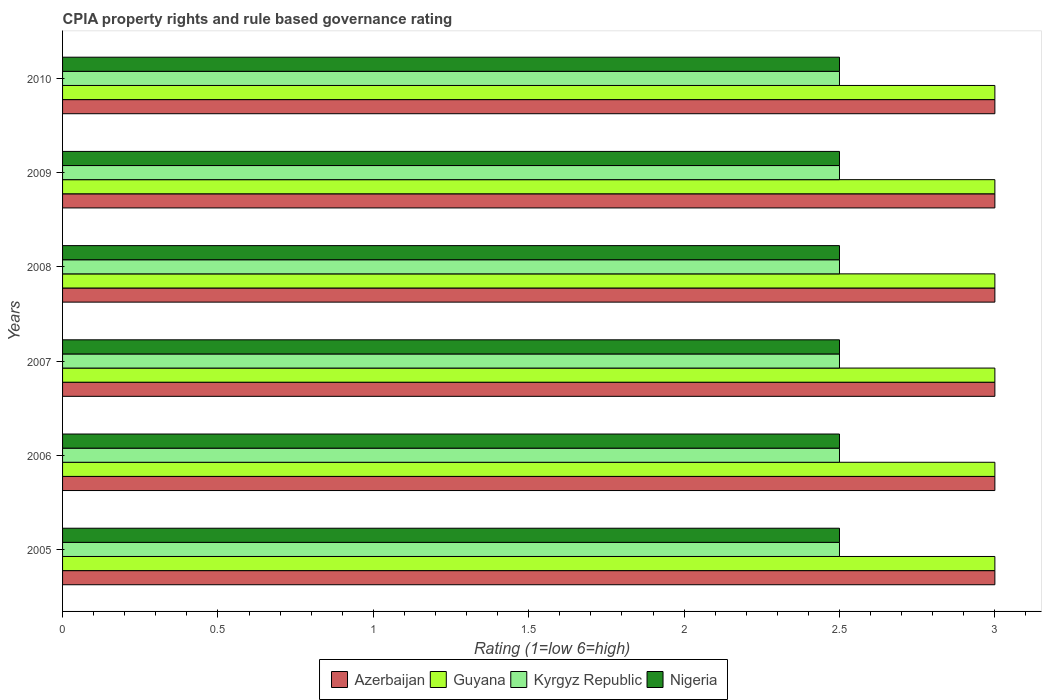How many groups of bars are there?
Make the answer very short. 6. Are the number of bars per tick equal to the number of legend labels?
Provide a short and direct response. Yes. Are the number of bars on each tick of the Y-axis equal?
Your answer should be very brief. Yes. How many bars are there on the 1st tick from the top?
Your answer should be very brief. 4. How many bars are there on the 4th tick from the bottom?
Keep it short and to the point. 4. What is the label of the 5th group of bars from the top?
Provide a succinct answer. 2006. In how many cases, is the number of bars for a given year not equal to the number of legend labels?
Give a very brief answer. 0. What is the total CPIA rating in Kyrgyz Republic in the graph?
Keep it short and to the point. 15. What is the difference between the CPIA rating in Azerbaijan in 2005 and that in 2006?
Your response must be concise. 0. In the year 2010, what is the difference between the CPIA rating in Guyana and CPIA rating in Azerbaijan?
Provide a succinct answer. 0. In how many years, is the CPIA rating in Kyrgyz Republic greater than 1.6 ?
Provide a short and direct response. 6. What is the ratio of the CPIA rating in Guyana in 2006 to that in 2010?
Give a very brief answer. 1. Is the sum of the CPIA rating in Kyrgyz Republic in 2005 and 2009 greater than the maximum CPIA rating in Nigeria across all years?
Ensure brevity in your answer.  Yes. Is it the case that in every year, the sum of the CPIA rating in Nigeria and CPIA rating in Kyrgyz Republic is greater than the sum of CPIA rating in Azerbaijan and CPIA rating in Guyana?
Ensure brevity in your answer.  No. What does the 2nd bar from the top in 2006 represents?
Make the answer very short. Kyrgyz Republic. What does the 2nd bar from the bottom in 2009 represents?
Give a very brief answer. Guyana. Is it the case that in every year, the sum of the CPIA rating in Kyrgyz Republic and CPIA rating in Nigeria is greater than the CPIA rating in Guyana?
Your answer should be very brief. Yes. Does the graph contain grids?
Make the answer very short. No. What is the title of the graph?
Provide a succinct answer. CPIA property rights and rule based governance rating. What is the label or title of the X-axis?
Give a very brief answer. Rating (1=low 6=high). What is the Rating (1=low 6=high) of Azerbaijan in 2005?
Your answer should be very brief. 3. What is the Rating (1=low 6=high) in Kyrgyz Republic in 2006?
Provide a short and direct response. 2.5. What is the Rating (1=low 6=high) in Nigeria in 2006?
Your answer should be compact. 2.5. What is the Rating (1=low 6=high) in Nigeria in 2007?
Make the answer very short. 2.5. What is the Rating (1=low 6=high) of Azerbaijan in 2008?
Provide a short and direct response. 3. What is the Rating (1=low 6=high) of Guyana in 2008?
Your response must be concise. 3. What is the Rating (1=low 6=high) of Guyana in 2009?
Offer a very short reply. 3. What is the Rating (1=low 6=high) of Nigeria in 2009?
Offer a very short reply. 2.5. What is the Rating (1=low 6=high) in Azerbaijan in 2010?
Your response must be concise. 3. What is the Rating (1=low 6=high) of Nigeria in 2010?
Your response must be concise. 2.5. Across all years, what is the maximum Rating (1=low 6=high) of Azerbaijan?
Keep it short and to the point. 3. Across all years, what is the maximum Rating (1=low 6=high) of Guyana?
Give a very brief answer. 3. Across all years, what is the maximum Rating (1=low 6=high) in Nigeria?
Your answer should be very brief. 2.5. Across all years, what is the minimum Rating (1=low 6=high) of Azerbaijan?
Keep it short and to the point. 3. Across all years, what is the minimum Rating (1=low 6=high) of Kyrgyz Republic?
Offer a very short reply. 2.5. What is the total Rating (1=low 6=high) of Azerbaijan in the graph?
Your answer should be very brief. 18. What is the total Rating (1=low 6=high) of Guyana in the graph?
Your response must be concise. 18. What is the total Rating (1=low 6=high) of Kyrgyz Republic in the graph?
Ensure brevity in your answer.  15. What is the difference between the Rating (1=low 6=high) of Guyana in 2005 and that in 2006?
Your response must be concise. 0. What is the difference between the Rating (1=low 6=high) in Kyrgyz Republic in 2005 and that in 2007?
Your response must be concise. 0. What is the difference between the Rating (1=low 6=high) of Nigeria in 2005 and that in 2007?
Provide a succinct answer. 0. What is the difference between the Rating (1=low 6=high) of Azerbaijan in 2005 and that in 2008?
Give a very brief answer. 0. What is the difference between the Rating (1=low 6=high) in Guyana in 2005 and that in 2008?
Your response must be concise. 0. What is the difference between the Rating (1=low 6=high) of Kyrgyz Republic in 2005 and that in 2008?
Make the answer very short. 0. What is the difference between the Rating (1=low 6=high) in Nigeria in 2005 and that in 2008?
Offer a terse response. 0. What is the difference between the Rating (1=low 6=high) in Azerbaijan in 2005 and that in 2009?
Provide a succinct answer. 0. What is the difference between the Rating (1=low 6=high) of Kyrgyz Republic in 2005 and that in 2009?
Provide a short and direct response. 0. What is the difference between the Rating (1=low 6=high) in Azerbaijan in 2005 and that in 2010?
Make the answer very short. 0. What is the difference between the Rating (1=low 6=high) in Kyrgyz Republic in 2005 and that in 2010?
Give a very brief answer. 0. What is the difference between the Rating (1=low 6=high) in Nigeria in 2005 and that in 2010?
Your answer should be very brief. 0. What is the difference between the Rating (1=low 6=high) of Nigeria in 2006 and that in 2007?
Keep it short and to the point. 0. What is the difference between the Rating (1=low 6=high) of Guyana in 2006 and that in 2008?
Offer a terse response. 0. What is the difference between the Rating (1=low 6=high) of Nigeria in 2006 and that in 2008?
Your response must be concise. 0. What is the difference between the Rating (1=low 6=high) of Guyana in 2006 and that in 2009?
Offer a very short reply. 0. What is the difference between the Rating (1=low 6=high) in Kyrgyz Republic in 2006 and that in 2009?
Your response must be concise. 0. What is the difference between the Rating (1=low 6=high) in Azerbaijan in 2006 and that in 2010?
Make the answer very short. 0. What is the difference between the Rating (1=low 6=high) of Guyana in 2006 and that in 2010?
Your response must be concise. 0. What is the difference between the Rating (1=low 6=high) of Kyrgyz Republic in 2006 and that in 2010?
Your answer should be compact. 0. What is the difference between the Rating (1=low 6=high) of Azerbaijan in 2007 and that in 2008?
Ensure brevity in your answer.  0. What is the difference between the Rating (1=low 6=high) in Azerbaijan in 2007 and that in 2009?
Your response must be concise. 0. What is the difference between the Rating (1=low 6=high) of Kyrgyz Republic in 2007 and that in 2009?
Give a very brief answer. 0. What is the difference between the Rating (1=low 6=high) in Nigeria in 2007 and that in 2009?
Your response must be concise. 0. What is the difference between the Rating (1=low 6=high) of Azerbaijan in 2008 and that in 2009?
Keep it short and to the point. 0. What is the difference between the Rating (1=low 6=high) in Guyana in 2008 and that in 2009?
Offer a very short reply. 0. What is the difference between the Rating (1=low 6=high) of Kyrgyz Republic in 2008 and that in 2009?
Keep it short and to the point. 0. What is the difference between the Rating (1=low 6=high) in Nigeria in 2008 and that in 2009?
Your answer should be compact. 0. What is the difference between the Rating (1=low 6=high) of Guyana in 2008 and that in 2010?
Ensure brevity in your answer.  0. What is the difference between the Rating (1=low 6=high) in Kyrgyz Republic in 2008 and that in 2010?
Provide a short and direct response. 0. What is the difference between the Rating (1=low 6=high) in Nigeria in 2008 and that in 2010?
Your response must be concise. 0. What is the difference between the Rating (1=low 6=high) of Guyana in 2009 and that in 2010?
Provide a short and direct response. 0. What is the difference between the Rating (1=low 6=high) in Kyrgyz Republic in 2009 and that in 2010?
Your answer should be very brief. 0. What is the difference between the Rating (1=low 6=high) in Nigeria in 2009 and that in 2010?
Your response must be concise. 0. What is the difference between the Rating (1=low 6=high) of Azerbaijan in 2005 and the Rating (1=low 6=high) of Guyana in 2006?
Offer a very short reply. 0. What is the difference between the Rating (1=low 6=high) in Azerbaijan in 2005 and the Rating (1=low 6=high) in Kyrgyz Republic in 2006?
Provide a succinct answer. 0.5. What is the difference between the Rating (1=low 6=high) of Guyana in 2005 and the Rating (1=low 6=high) of Kyrgyz Republic in 2006?
Keep it short and to the point. 0.5. What is the difference between the Rating (1=low 6=high) in Guyana in 2005 and the Rating (1=low 6=high) in Nigeria in 2006?
Your answer should be very brief. 0.5. What is the difference between the Rating (1=low 6=high) in Azerbaijan in 2005 and the Rating (1=low 6=high) in Guyana in 2007?
Your answer should be compact. 0. What is the difference between the Rating (1=low 6=high) in Kyrgyz Republic in 2005 and the Rating (1=low 6=high) in Nigeria in 2007?
Make the answer very short. 0. What is the difference between the Rating (1=low 6=high) of Azerbaijan in 2005 and the Rating (1=low 6=high) of Kyrgyz Republic in 2008?
Give a very brief answer. 0.5. What is the difference between the Rating (1=low 6=high) in Kyrgyz Republic in 2005 and the Rating (1=low 6=high) in Nigeria in 2008?
Give a very brief answer. 0. What is the difference between the Rating (1=low 6=high) of Azerbaijan in 2005 and the Rating (1=low 6=high) of Kyrgyz Republic in 2009?
Provide a succinct answer. 0.5. What is the difference between the Rating (1=low 6=high) in Azerbaijan in 2005 and the Rating (1=low 6=high) in Nigeria in 2009?
Your response must be concise. 0.5. What is the difference between the Rating (1=low 6=high) of Azerbaijan in 2005 and the Rating (1=low 6=high) of Nigeria in 2010?
Your response must be concise. 0.5. What is the difference between the Rating (1=low 6=high) in Guyana in 2005 and the Rating (1=low 6=high) in Kyrgyz Republic in 2010?
Your answer should be very brief. 0.5. What is the difference between the Rating (1=low 6=high) of Kyrgyz Republic in 2005 and the Rating (1=low 6=high) of Nigeria in 2010?
Offer a very short reply. 0. What is the difference between the Rating (1=low 6=high) of Azerbaijan in 2006 and the Rating (1=low 6=high) of Kyrgyz Republic in 2007?
Make the answer very short. 0.5. What is the difference between the Rating (1=low 6=high) in Azerbaijan in 2006 and the Rating (1=low 6=high) in Nigeria in 2007?
Offer a very short reply. 0.5. What is the difference between the Rating (1=low 6=high) of Guyana in 2006 and the Rating (1=low 6=high) of Kyrgyz Republic in 2007?
Offer a terse response. 0.5. What is the difference between the Rating (1=low 6=high) of Guyana in 2006 and the Rating (1=low 6=high) of Nigeria in 2007?
Ensure brevity in your answer.  0.5. What is the difference between the Rating (1=low 6=high) of Azerbaijan in 2006 and the Rating (1=low 6=high) of Guyana in 2008?
Keep it short and to the point. 0. What is the difference between the Rating (1=low 6=high) of Guyana in 2006 and the Rating (1=low 6=high) of Nigeria in 2008?
Your answer should be compact. 0.5. What is the difference between the Rating (1=low 6=high) of Kyrgyz Republic in 2006 and the Rating (1=low 6=high) of Nigeria in 2008?
Ensure brevity in your answer.  0. What is the difference between the Rating (1=low 6=high) in Azerbaijan in 2006 and the Rating (1=low 6=high) in Nigeria in 2009?
Your response must be concise. 0.5. What is the difference between the Rating (1=low 6=high) in Guyana in 2006 and the Rating (1=low 6=high) in Kyrgyz Republic in 2009?
Provide a succinct answer. 0.5. What is the difference between the Rating (1=low 6=high) of Guyana in 2006 and the Rating (1=low 6=high) of Nigeria in 2009?
Keep it short and to the point. 0.5. What is the difference between the Rating (1=low 6=high) in Guyana in 2006 and the Rating (1=low 6=high) in Kyrgyz Republic in 2010?
Your answer should be very brief. 0.5. What is the difference between the Rating (1=low 6=high) in Azerbaijan in 2007 and the Rating (1=low 6=high) in Guyana in 2008?
Your answer should be compact. 0. What is the difference between the Rating (1=low 6=high) in Azerbaijan in 2007 and the Rating (1=low 6=high) in Kyrgyz Republic in 2008?
Your answer should be very brief. 0.5. What is the difference between the Rating (1=low 6=high) in Kyrgyz Republic in 2007 and the Rating (1=low 6=high) in Nigeria in 2008?
Offer a terse response. 0. What is the difference between the Rating (1=low 6=high) of Azerbaijan in 2007 and the Rating (1=low 6=high) of Guyana in 2009?
Ensure brevity in your answer.  0. What is the difference between the Rating (1=low 6=high) of Azerbaijan in 2007 and the Rating (1=low 6=high) of Nigeria in 2009?
Make the answer very short. 0.5. What is the difference between the Rating (1=low 6=high) in Guyana in 2007 and the Rating (1=low 6=high) in Kyrgyz Republic in 2009?
Your answer should be compact. 0.5. What is the difference between the Rating (1=low 6=high) in Azerbaijan in 2007 and the Rating (1=low 6=high) in Kyrgyz Republic in 2010?
Offer a very short reply. 0.5. What is the difference between the Rating (1=low 6=high) of Azerbaijan in 2007 and the Rating (1=low 6=high) of Nigeria in 2010?
Offer a terse response. 0.5. What is the difference between the Rating (1=low 6=high) of Azerbaijan in 2008 and the Rating (1=low 6=high) of Guyana in 2009?
Your answer should be very brief. 0. What is the difference between the Rating (1=low 6=high) in Azerbaijan in 2008 and the Rating (1=low 6=high) in Kyrgyz Republic in 2009?
Make the answer very short. 0.5. What is the difference between the Rating (1=low 6=high) in Guyana in 2008 and the Rating (1=low 6=high) in Nigeria in 2009?
Offer a very short reply. 0.5. What is the difference between the Rating (1=low 6=high) of Azerbaijan in 2008 and the Rating (1=low 6=high) of Guyana in 2010?
Keep it short and to the point. 0. What is the difference between the Rating (1=low 6=high) of Azerbaijan in 2008 and the Rating (1=low 6=high) of Nigeria in 2010?
Provide a succinct answer. 0.5. What is the difference between the Rating (1=low 6=high) of Guyana in 2008 and the Rating (1=low 6=high) of Kyrgyz Republic in 2010?
Offer a very short reply. 0.5. What is the difference between the Rating (1=low 6=high) in Guyana in 2008 and the Rating (1=low 6=high) in Nigeria in 2010?
Offer a terse response. 0.5. What is the difference between the Rating (1=low 6=high) of Kyrgyz Republic in 2008 and the Rating (1=low 6=high) of Nigeria in 2010?
Your answer should be very brief. 0. What is the difference between the Rating (1=low 6=high) in Azerbaijan in 2009 and the Rating (1=low 6=high) in Guyana in 2010?
Provide a short and direct response. 0. What is the difference between the Rating (1=low 6=high) of Azerbaijan in 2009 and the Rating (1=low 6=high) of Kyrgyz Republic in 2010?
Give a very brief answer. 0.5. What is the difference between the Rating (1=low 6=high) in Azerbaijan in 2009 and the Rating (1=low 6=high) in Nigeria in 2010?
Your answer should be compact. 0.5. What is the difference between the Rating (1=low 6=high) of Guyana in 2009 and the Rating (1=low 6=high) of Kyrgyz Republic in 2010?
Your answer should be very brief. 0.5. What is the average Rating (1=low 6=high) in Guyana per year?
Provide a short and direct response. 3. What is the average Rating (1=low 6=high) in Kyrgyz Republic per year?
Your answer should be compact. 2.5. What is the average Rating (1=low 6=high) in Nigeria per year?
Keep it short and to the point. 2.5. In the year 2005, what is the difference between the Rating (1=low 6=high) of Azerbaijan and Rating (1=low 6=high) of Guyana?
Give a very brief answer. 0. In the year 2005, what is the difference between the Rating (1=low 6=high) of Guyana and Rating (1=low 6=high) of Nigeria?
Your response must be concise. 0.5. In the year 2006, what is the difference between the Rating (1=low 6=high) of Azerbaijan and Rating (1=low 6=high) of Nigeria?
Provide a succinct answer. 0.5. In the year 2006, what is the difference between the Rating (1=low 6=high) of Guyana and Rating (1=low 6=high) of Kyrgyz Republic?
Provide a short and direct response. 0.5. In the year 2006, what is the difference between the Rating (1=low 6=high) in Guyana and Rating (1=low 6=high) in Nigeria?
Your answer should be compact. 0.5. In the year 2006, what is the difference between the Rating (1=low 6=high) of Kyrgyz Republic and Rating (1=low 6=high) of Nigeria?
Keep it short and to the point. 0. In the year 2007, what is the difference between the Rating (1=low 6=high) in Azerbaijan and Rating (1=low 6=high) in Kyrgyz Republic?
Provide a short and direct response. 0.5. In the year 2007, what is the difference between the Rating (1=low 6=high) in Guyana and Rating (1=low 6=high) in Kyrgyz Republic?
Your answer should be compact. 0.5. In the year 2007, what is the difference between the Rating (1=low 6=high) of Kyrgyz Republic and Rating (1=low 6=high) of Nigeria?
Offer a very short reply. 0. In the year 2008, what is the difference between the Rating (1=low 6=high) in Azerbaijan and Rating (1=low 6=high) in Guyana?
Offer a terse response. 0. In the year 2008, what is the difference between the Rating (1=low 6=high) in Azerbaijan and Rating (1=low 6=high) in Kyrgyz Republic?
Offer a terse response. 0.5. In the year 2008, what is the difference between the Rating (1=low 6=high) of Guyana and Rating (1=low 6=high) of Nigeria?
Your response must be concise. 0.5. In the year 2008, what is the difference between the Rating (1=low 6=high) of Kyrgyz Republic and Rating (1=low 6=high) of Nigeria?
Give a very brief answer. 0. In the year 2009, what is the difference between the Rating (1=low 6=high) of Azerbaijan and Rating (1=low 6=high) of Nigeria?
Ensure brevity in your answer.  0.5. In the year 2009, what is the difference between the Rating (1=low 6=high) of Guyana and Rating (1=low 6=high) of Kyrgyz Republic?
Provide a short and direct response. 0.5. In the year 2009, what is the difference between the Rating (1=low 6=high) in Guyana and Rating (1=low 6=high) in Nigeria?
Your answer should be very brief. 0.5. In the year 2009, what is the difference between the Rating (1=low 6=high) of Kyrgyz Republic and Rating (1=low 6=high) of Nigeria?
Keep it short and to the point. 0. In the year 2010, what is the difference between the Rating (1=low 6=high) in Azerbaijan and Rating (1=low 6=high) in Guyana?
Your answer should be compact. 0. In the year 2010, what is the difference between the Rating (1=low 6=high) of Azerbaijan and Rating (1=low 6=high) of Nigeria?
Ensure brevity in your answer.  0.5. In the year 2010, what is the difference between the Rating (1=low 6=high) of Guyana and Rating (1=low 6=high) of Kyrgyz Republic?
Provide a succinct answer. 0.5. In the year 2010, what is the difference between the Rating (1=low 6=high) of Guyana and Rating (1=low 6=high) of Nigeria?
Provide a short and direct response. 0.5. What is the ratio of the Rating (1=low 6=high) of Guyana in 2005 to that in 2006?
Offer a very short reply. 1. What is the ratio of the Rating (1=low 6=high) of Guyana in 2005 to that in 2007?
Offer a very short reply. 1. What is the ratio of the Rating (1=low 6=high) of Kyrgyz Republic in 2005 to that in 2007?
Your answer should be compact. 1. What is the ratio of the Rating (1=low 6=high) of Azerbaijan in 2005 to that in 2008?
Make the answer very short. 1. What is the ratio of the Rating (1=low 6=high) in Guyana in 2005 to that in 2008?
Keep it short and to the point. 1. What is the ratio of the Rating (1=low 6=high) of Kyrgyz Republic in 2005 to that in 2008?
Your response must be concise. 1. What is the ratio of the Rating (1=low 6=high) in Nigeria in 2005 to that in 2008?
Offer a terse response. 1. What is the ratio of the Rating (1=low 6=high) of Azerbaijan in 2005 to that in 2009?
Offer a very short reply. 1. What is the ratio of the Rating (1=low 6=high) in Kyrgyz Republic in 2005 to that in 2009?
Provide a succinct answer. 1. What is the ratio of the Rating (1=low 6=high) of Azerbaijan in 2005 to that in 2010?
Your answer should be compact. 1. What is the ratio of the Rating (1=low 6=high) in Guyana in 2005 to that in 2010?
Provide a succinct answer. 1. What is the ratio of the Rating (1=low 6=high) in Kyrgyz Republic in 2005 to that in 2010?
Provide a short and direct response. 1. What is the ratio of the Rating (1=low 6=high) in Guyana in 2006 to that in 2007?
Provide a short and direct response. 1. What is the ratio of the Rating (1=low 6=high) of Kyrgyz Republic in 2006 to that in 2007?
Your response must be concise. 1. What is the ratio of the Rating (1=low 6=high) of Nigeria in 2006 to that in 2007?
Your answer should be very brief. 1. What is the ratio of the Rating (1=low 6=high) in Azerbaijan in 2006 to that in 2008?
Keep it short and to the point. 1. What is the ratio of the Rating (1=low 6=high) of Guyana in 2006 to that in 2008?
Ensure brevity in your answer.  1. What is the ratio of the Rating (1=low 6=high) in Kyrgyz Republic in 2006 to that in 2008?
Provide a short and direct response. 1. What is the ratio of the Rating (1=low 6=high) of Azerbaijan in 2006 to that in 2009?
Provide a short and direct response. 1. What is the ratio of the Rating (1=low 6=high) of Kyrgyz Republic in 2006 to that in 2009?
Give a very brief answer. 1. What is the ratio of the Rating (1=low 6=high) in Nigeria in 2006 to that in 2009?
Offer a terse response. 1. What is the ratio of the Rating (1=low 6=high) in Azerbaijan in 2006 to that in 2010?
Make the answer very short. 1. What is the ratio of the Rating (1=low 6=high) in Guyana in 2006 to that in 2010?
Provide a short and direct response. 1. What is the ratio of the Rating (1=low 6=high) of Kyrgyz Republic in 2006 to that in 2010?
Provide a succinct answer. 1. What is the ratio of the Rating (1=low 6=high) of Nigeria in 2007 to that in 2008?
Your answer should be very brief. 1. What is the ratio of the Rating (1=low 6=high) of Azerbaijan in 2007 to that in 2009?
Your answer should be compact. 1. What is the ratio of the Rating (1=low 6=high) in Guyana in 2007 to that in 2009?
Offer a terse response. 1. What is the ratio of the Rating (1=low 6=high) of Kyrgyz Republic in 2007 to that in 2009?
Give a very brief answer. 1. What is the ratio of the Rating (1=low 6=high) in Guyana in 2007 to that in 2010?
Your answer should be very brief. 1. What is the ratio of the Rating (1=low 6=high) of Nigeria in 2007 to that in 2010?
Your response must be concise. 1. What is the ratio of the Rating (1=low 6=high) of Azerbaijan in 2008 to that in 2009?
Give a very brief answer. 1. What is the ratio of the Rating (1=low 6=high) in Kyrgyz Republic in 2008 to that in 2009?
Provide a succinct answer. 1. What is the ratio of the Rating (1=low 6=high) of Guyana in 2008 to that in 2010?
Ensure brevity in your answer.  1. What is the ratio of the Rating (1=low 6=high) of Nigeria in 2008 to that in 2010?
Provide a short and direct response. 1. What is the ratio of the Rating (1=low 6=high) of Azerbaijan in 2009 to that in 2010?
Your response must be concise. 1. What is the ratio of the Rating (1=low 6=high) of Kyrgyz Republic in 2009 to that in 2010?
Provide a succinct answer. 1. What is the ratio of the Rating (1=low 6=high) of Nigeria in 2009 to that in 2010?
Your answer should be compact. 1. What is the difference between the highest and the second highest Rating (1=low 6=high) in Nigeria?
Give a very brief answer. 0. What is the difference between the highest and the lowest Rating (1=low 6=high) in Azerbaijan?
Provide a short and direct response. 0. What is the difference between the highest and the lowest Rating (1=low 6=high) of Nigeria?
Offer a very short reply. 0. 